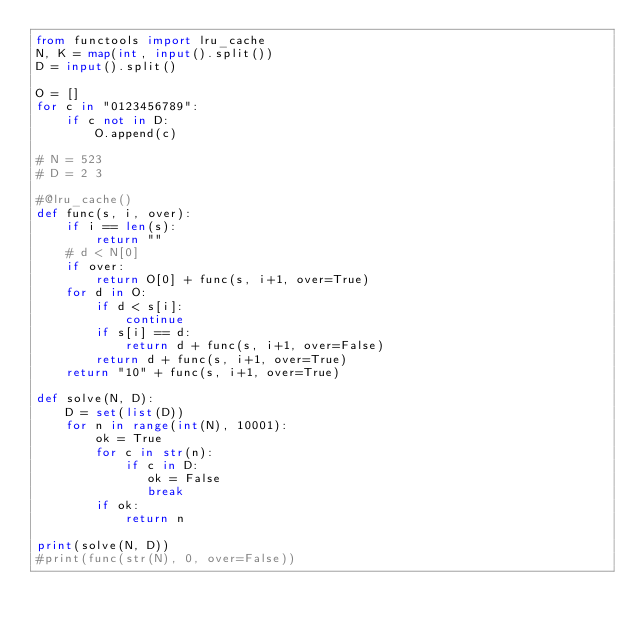Convert code to text. <code><loc_0><loc_0><loc_500><loc_500><_Python_>from functools import lru_cache
N, K = map(int, input().split())
D = input().split()

O = []
for c in "0123456789":
    if c not in D:
        O.append(c)

# N = 523
# D = 2 3

#@lru_cache()
def func(s, i, over):
    if i == len(s):
        return ""
    # d < N[0] 
    if over:
        return O[0] + func(s, i+1, over=True)
    for d in O:
        if d < s[i]:
            continue
        if s[i] == d:
            return d + func(s, i+1, over=False)
        return d + func(s, i+1, over=True)
    return "10" + func(s, i+1, over=True)

def solve(N, D):
    D = set(list(D))
    for n in range(int(N), 10001):
        ok = True
        for c in str(n):
            if c in D:
               ok = False
               break
        if ok:
            return n

print(solve(N, D))
#print(func(str(N), 0, over=False))</code> 